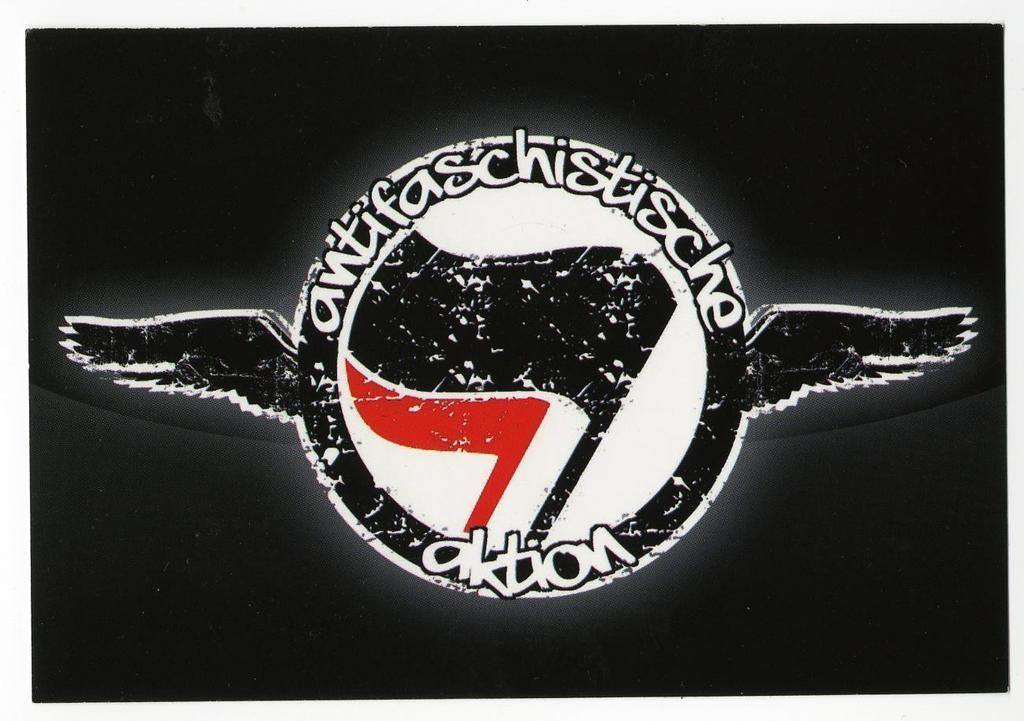What is the main subject in the center of the image? There is an antifa in the center of the image. What type of destruction is being caused by the oven in the image? There is no oven present in the image, and therefore no destruction can be observed. What idea is being expressed by the antifa in the image? The image does not convey any specific idea or message; it simply shows an antifa in the center. 